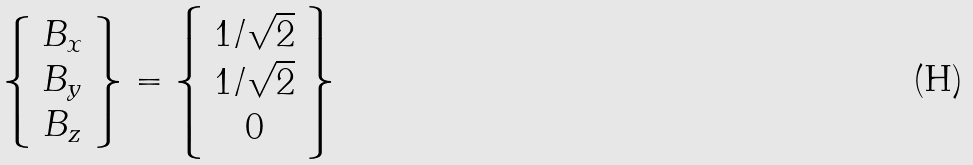Convert formula to latex. <formula><loc_0><loc_0><loc_500><loc_500>\left \{ \begin{array} { c } B _ { x } \\ B _ { y } \\ B _ { z } \end{array} \right \} = \left \{ \begin{array} { c } 1 / \sqrt { 2 } \\ 1 / \sqrt { 2 } \\ 0 \end{array} \right \}</formula> 